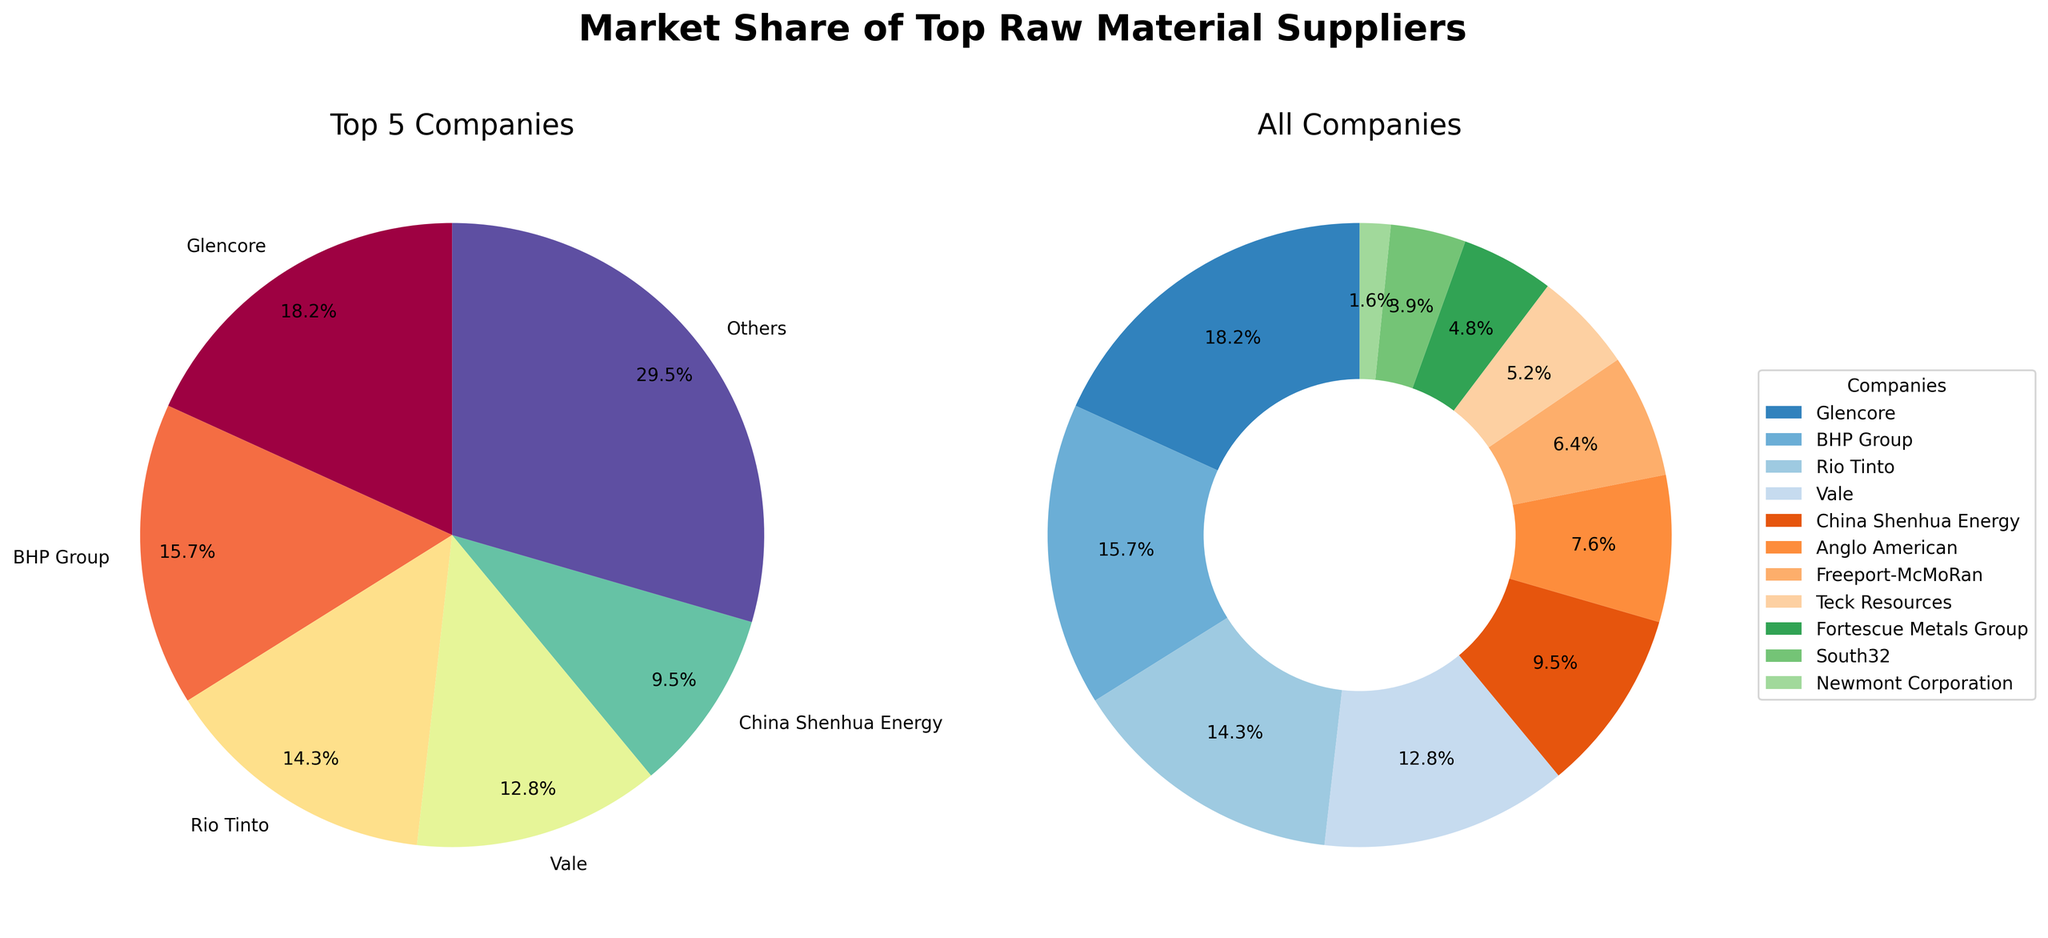How much market share do the top 5 companies hold combined? First, add up the market shares of the top 5 companies: Glencore (18.2%), BHP Group (15.7%), Rio Tinto (14.3%), Vale (12.8%), and China Shenhua Energy (9.5%). The calculation is 18.2 + 15.7 + 14.3 + 12.8 + 9.5 = 70.5%
Answer: 70.5% What is the total market share of the companies labeled as "Others" in the left pie chart? The slice labeled "Others" represents companies outside the top 5. According to the left pie chart, "Others" have a market share of 29.5%. This value should be calculated by summing the market shares of all companies and subtracting the market shares of the top 5 companies from the total.
Answer: 29.5% Which company has the smallest market share and what is it? By looking at the donut chart, Newmont Corporation has the smallest segment. The legend also shows Newmont Corporation with a market share of 1.6%, the smallest among all listed companies.
Answer: Newmont Corporation, 1.6% How does the market share of Glencore compare to Rio Tinto? By comparing the slices in both the left and right pie charts, Glencore has a larger slice than Rio Tinto. Specifically, Glencore's market share is 18.2% while Rio Tinto's market share is 14.3%. Therefore, Glencore’s share is greater than Rio Tinto’s.
Answer: Glencore > Rio Tinto Which company has a market share closest to 10% and what is that value? Observing the pie chart, China Shenhua Energy has a market share of 9.5%, closest to 10%. This can be seen both in the slice size and the percentage label on the charts.
Answer: China Shenhua Energy, 9.5% What is the difference in market share between Teck Resources and Fortescue Metals Group? Subtract the market share of Fortescue Metals Group (4.8%) from that of Teck Resources (5.2%). The calculation is 5.2 - 4.8 = 0.4%.
Answer: 0.4% Among the top 5 companies, which one has the second-largest market share and what is the percentage? In the left pie chart, Glencore has the largest share at 18.2%. The second largest is BHP Group at 15.7%. This can be verified by size and labels provided.
Answer: BHP Group, 15.7% How many companies have a market share less than 5%? By looking at the percentages in the right donut chart, companies with market shares less than 5% are: Teck Resources (5.2% just above 5%), Fortescue Metals Group (4.8%), South32 (3.9%), and Newmont Corporation (1.6%). Only 3 companies meet the criterion.
Answer: 3 What is the cumulative market share of Anglo American, Freeport-McMoRan, and South32? Adding up the market shares of these three companies results in: Anglo American (7.6%) + Freeport-McMoRan (6.4%) + South32 (3.9%). The calculation is 7.6 + 6.4 + 3.9 = 17.9%.
Answer: 17.9% What color represents Vale in the right donut chart? Looking at the right donut chart, Vale is represented by the fourth slice from the start angle. Using the legends provided, the slice corresponding to Vale is colored light green.
Answer: Light green 